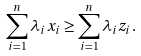Convert formula to latex. <formula><loc_0><loc_0><loc_500><loc_500>\sum _ { i = 1 } ^ { n } \lambda _ { i } x _ { i } & \geq \sum _ { i = 1 } ^ { n } \lambda _ { i } z _ { i } .</formula> 